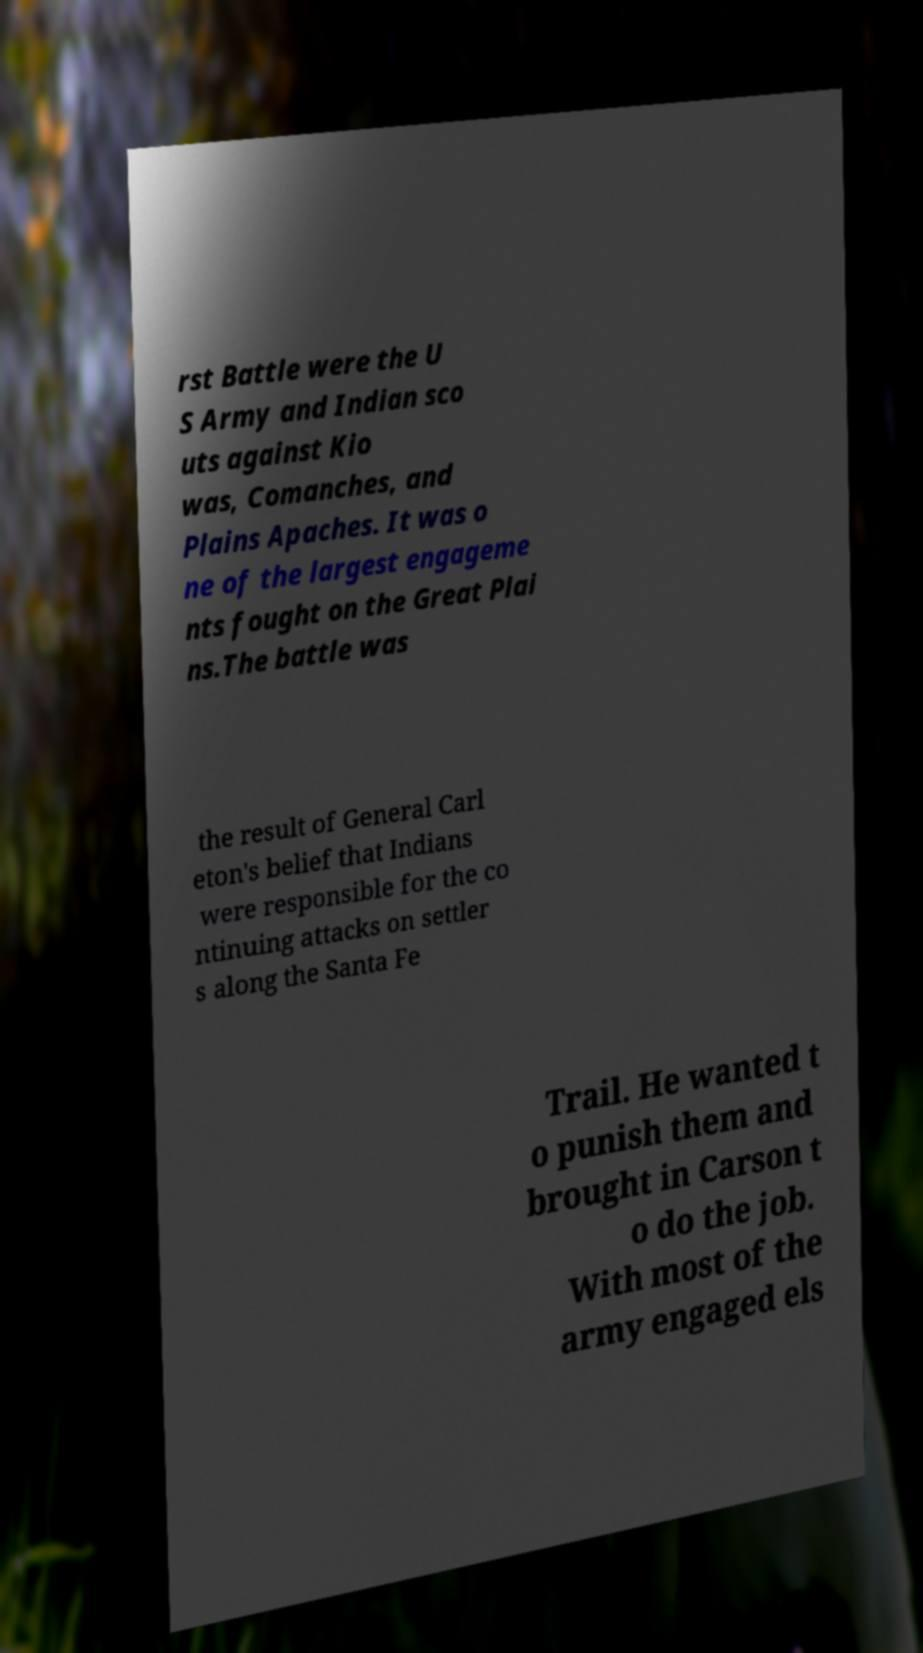Can you read and provide the text displayed in the image?This photo seems to have some interesting text. Can you extract and type it out for me? rst Battle were the U S Army and Indian sco uts against Kio was, Comanches, and Plains Apaches. It was o ne of the largest engageme nts fought on the Great Plai ns.The battle was the result of General Carl eton's belief that Indians were responsible for the co ntinuing attacks on settler s along the Santa Fe Trail. He wanted t o punish them and brought in Carson t o do the job. With most of the army engaged els 